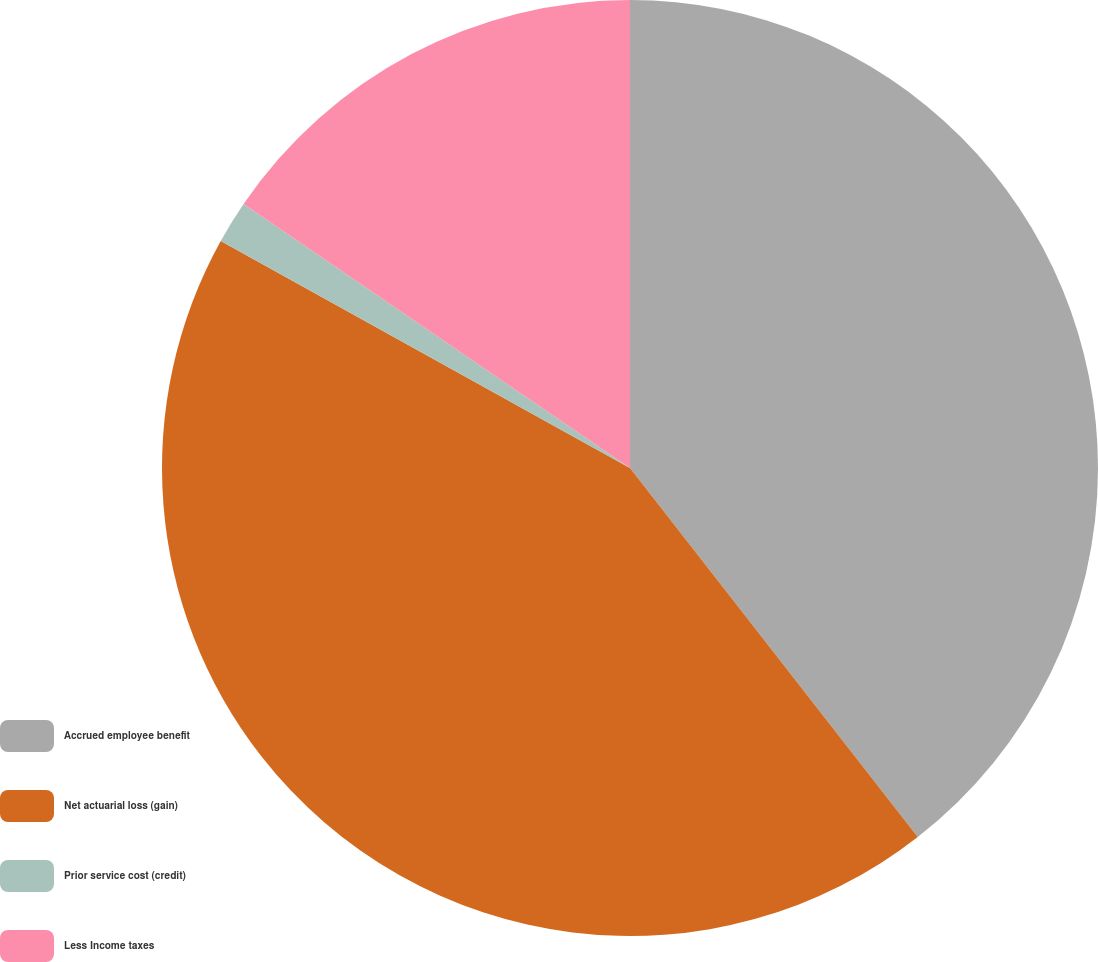Convert chart. <chart><loc_0><loc_0><loc_500><loc_500><pie_chart><fcel>Accrued employee benefit<fcel>Net actuarial loss (gain)<fcel>Prior service cost (credit)<fcel>Less Income taxes<nl><fcel>39.46%<fcel>43.6%<fcel>1.48%<fcel>15.46%<nl></chart> 